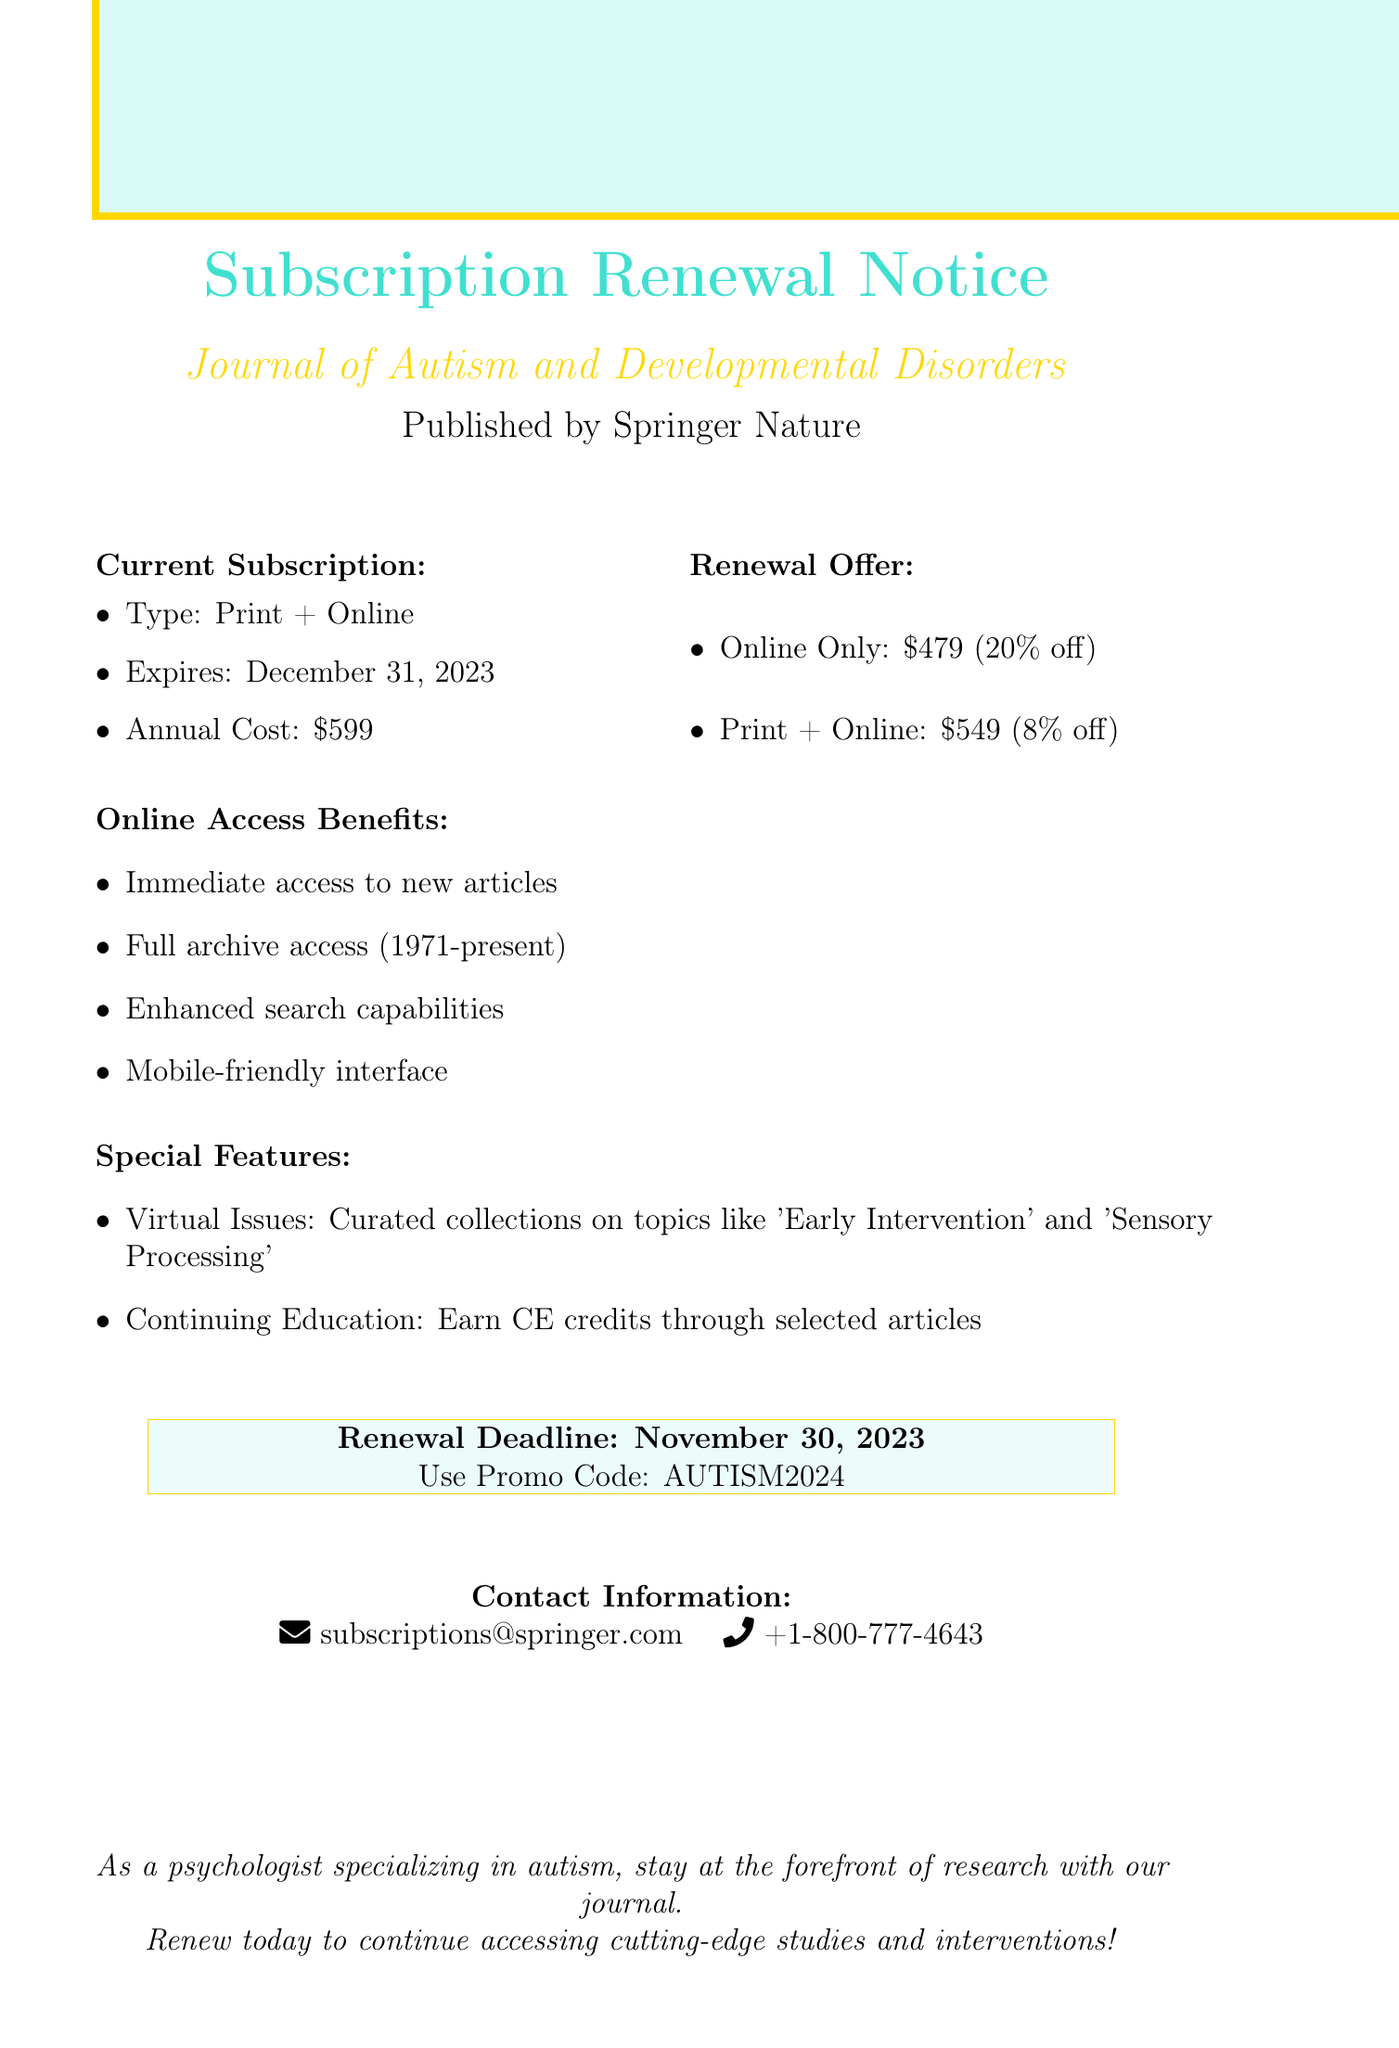What is the name of the journal? The name of the journal is highlighted in the document as "Journal of Autism and Developmental Disorders."
Answer: Journal of Autism and Developmental Disorders Who is the publisher? The publisher is specifically mentioned in the document as "Springer Nature."
Answer: Springer Nature What is the annual cost of the current subscription? The document states that the annual cost of the current subscription is $599.
Answer: $599 What is the deadline for renewal? The renewal deadline is specifically provided in the document as November 30, 2023.
Answer: November 30, 2023 What discount is offered for the online-only option? The document mentions that the discount for the online-only option is 20%.
Answer: 20% What are the benefits of online access? This information is detailed in the document and highlights features like "Immediate access to new articles."
Answer: Immediate access to new articles How many years of archive access are available? The document states that there is full archive access from 1971 to the present.
Answer: 1971-present What promotional code is provided for the renewal? The promotional code for renewal is provided clearly in the document as "AUTISM2024."
Answer: AUTISM2024 What special feature allows earning credits? The document specifies that "Continuing Education" allows earning CE credits through selected articles.
Answer: Continuing Education 